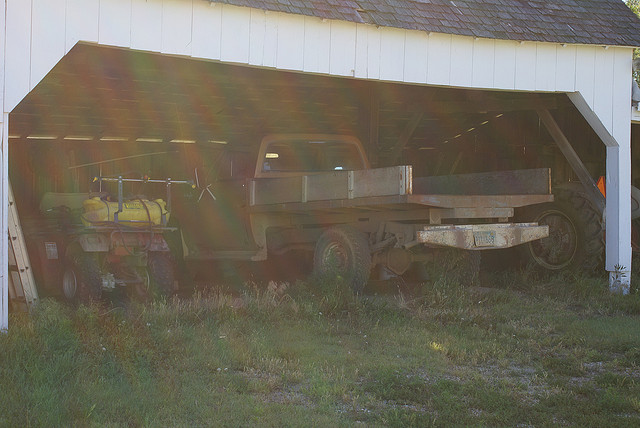<image>What part of the train is this? It is unknown what part of the train this is, as a train is not pictured. However, it could possibly be the front, rear, end, or side. What part of the train is this? It is unknown what part of the train is shown in the image. 